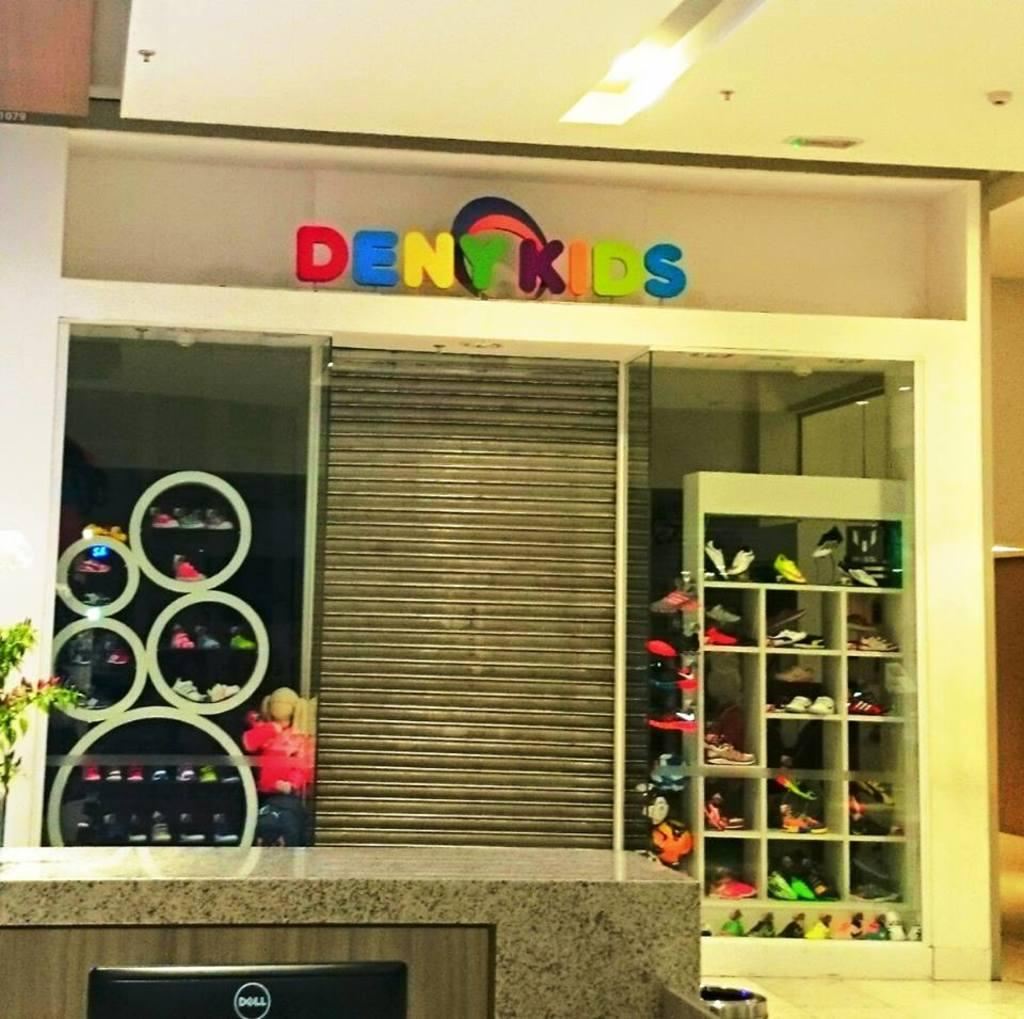What is placed on an object in the image? There are footwear placed on an object in the image. What is written above the object with footwear? The object has "deny kids" written above it. What type of furniture is visible in the image? There is a desktop in the image. What brand is the desktop? The desktop has "dell" written on it in the left bottom corner. What type of shirt is visible on the desktop in the image? There is no shirt visible on the desktop in the image. What type of mineral is present on the desktop in the image? There is no mineral present on the desktop in the image. 